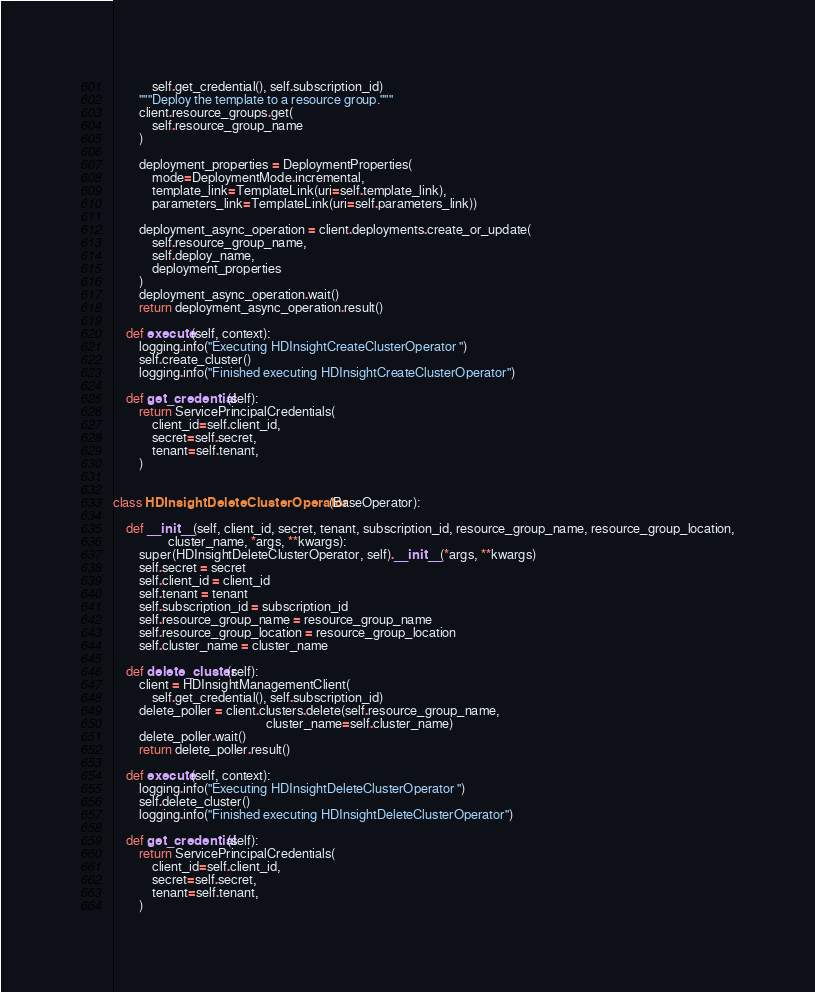<code> <loc_0><loc_0><loc_500><loc_500><_Python_>            self.get_credential(), self.subscription_id)
        """Deploy the template to a resource group."""
        client.resource_groups.get(
            self.resource_group_name
        )

        deployment_properties = DeploymentProperties(
            mode=DeploymentMode.incremental,
            template_link=TemplateLink(uri=self.template_link),
            parameters_link=TemplateLink(uri=self.parameters_link))

        deployment_async_operation = client.deployments.create_or_update(
            self.resource_group_name,
            self.deploy_name,
            deployment_properties
        )
        deployment_async_operation.wait()
        return deployment_async_operation.result()

    def execute(self, context):
        logging.info("Executing HDInsightCreateClusterOperator ")
        self.create_cluster()
        logging.info("Finished executing HDInsightCreateClusterOperator")

    def get_credential(self):
        return ServicePrincipalCredentials(
            client_id=self.client_id,
            secret=self.secret,
            tenant=self.tenant,
        )


class HDInsightDeleteClusterOperator(BaseOperator):

    def __init__(self, client_id, secret, tenant, subscription_id, resource_group_name, resource_group_location,
                 cluster_name, *args, **kwargs):
        super(HDInsightDeleteClusterOperator, self).__init__(*args, **kwargs)
        self.secret = secret
        self.client_id = client_id
        self.tenant = tenant
        self.subscription_id = subscription_id
        self.resource_group_name = resource_group_name
        self.resource_group_location = resource_group_location
        self.cluster_name = cluster_name

    def delete_cluster(self):
        client = HDInsightManagementClient(
            self.get_credential(), self.subscription_id)
        delete_poller = client.clusters.delete(self.resource_group_name,
                                               cluster_name=self.cluster_name)
        delete_poller.wait()
        return delete_poller.result()

    def execute(self, context):
        logging.info("Executing HDInsightDeleteClusterOperator ")
        self.delete_cluster()
        logging.info("Finished executing HDInsightDeleteClusterOperator")

    def get_credential(self):
        return ServicePrincipalCredentials(
            client_id=self.client_id,
            secret=self.secret,
            tenant=self.tenant,
        )
</code> 